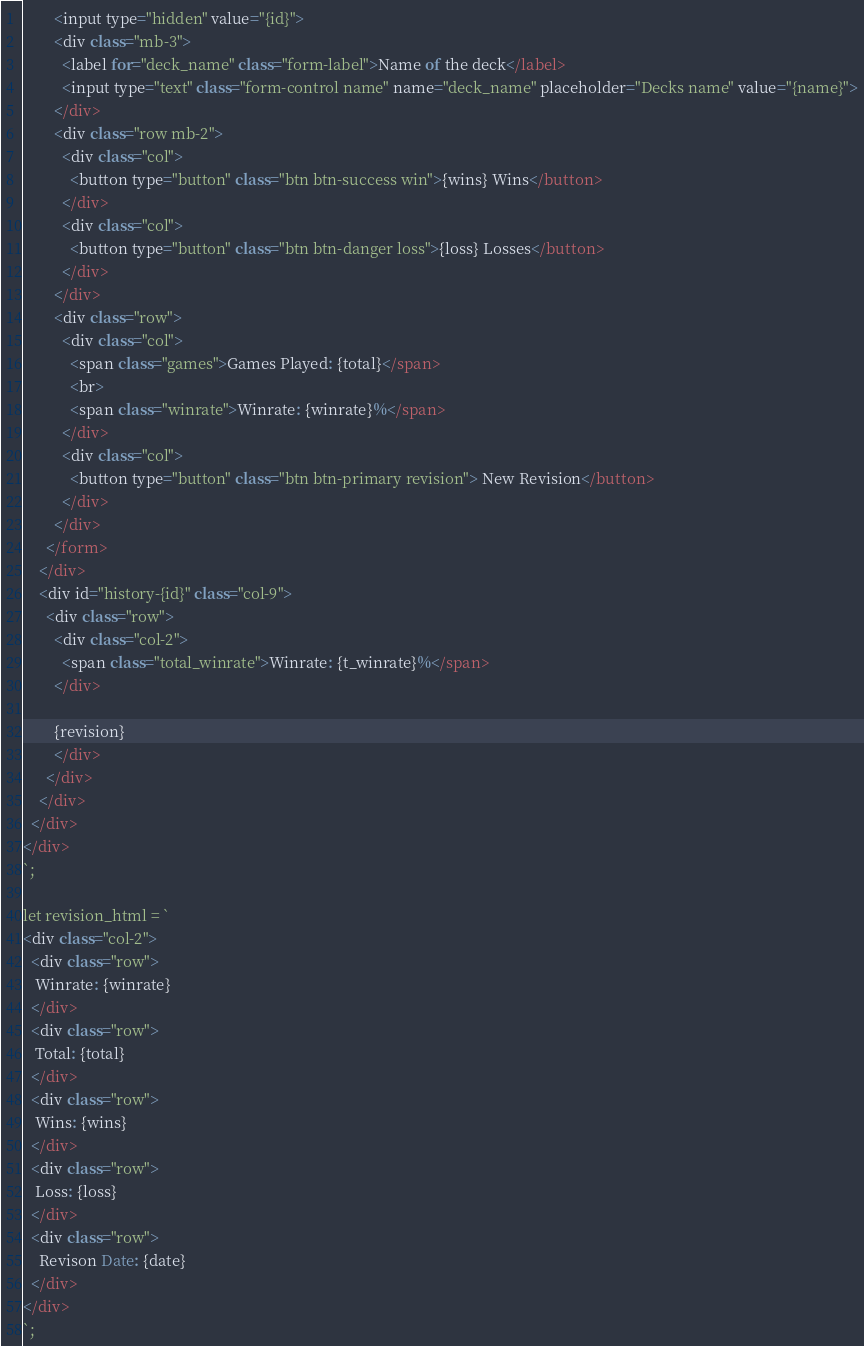Convert code to text. <code><loc_0><loc_0><loc_500><loc_500><_JavaScript_>        <input type="hidden" value="{id}">
        <div class="mb-3">
          <label for="deck_name" class="form-label">Name of the deck</label>
          <input type="text" class="form-control name" name="deck_name" placeholder="Decks name" value="{name}">
        </div>
        <div class="row mb-2">
          <div class="col">
            <button type="button" class="btn btn-success win">{wins} Wins</button>
          </div>
          <div class="col">
            <button type="button" class="btn btn-danger loss">{loss} Losses</button>
          </div>
        </div>
        <div class="row">
          <div class="col">
            <span class="games">Games Played: {total}</span>
            <br>
            <span class="winrate">Winrate: {winrate}%</span>
          </div>
          <div class="col">
            <button type="button" class="btn btn-primary revision"> New Revision</button>
          </div>
        </div>
      </form>
    </div>
    <div id="history-{id}" class="col-9">
      <div class="row">
        <div class="col-2">
          <span class="total_winrate">Winrate: {t_winrate}%</span>
        </div>

        {revision}
        </div>
      </div>
    </div>
  </div>
</div>
`;

let revision_html = `
<div class="col-2">
  <div class="row">
   Winrate: {winrate}
  </div>
  <div class="row">
   Total: {total}
  </div>
  <div class="row">
   Wins: {wins}
  </div>
  <div class="row">
   Loss: {loss}
  </div>
  <div class="row">
    Revison Date: {date}
  </div>
</div>
`;
</code> 